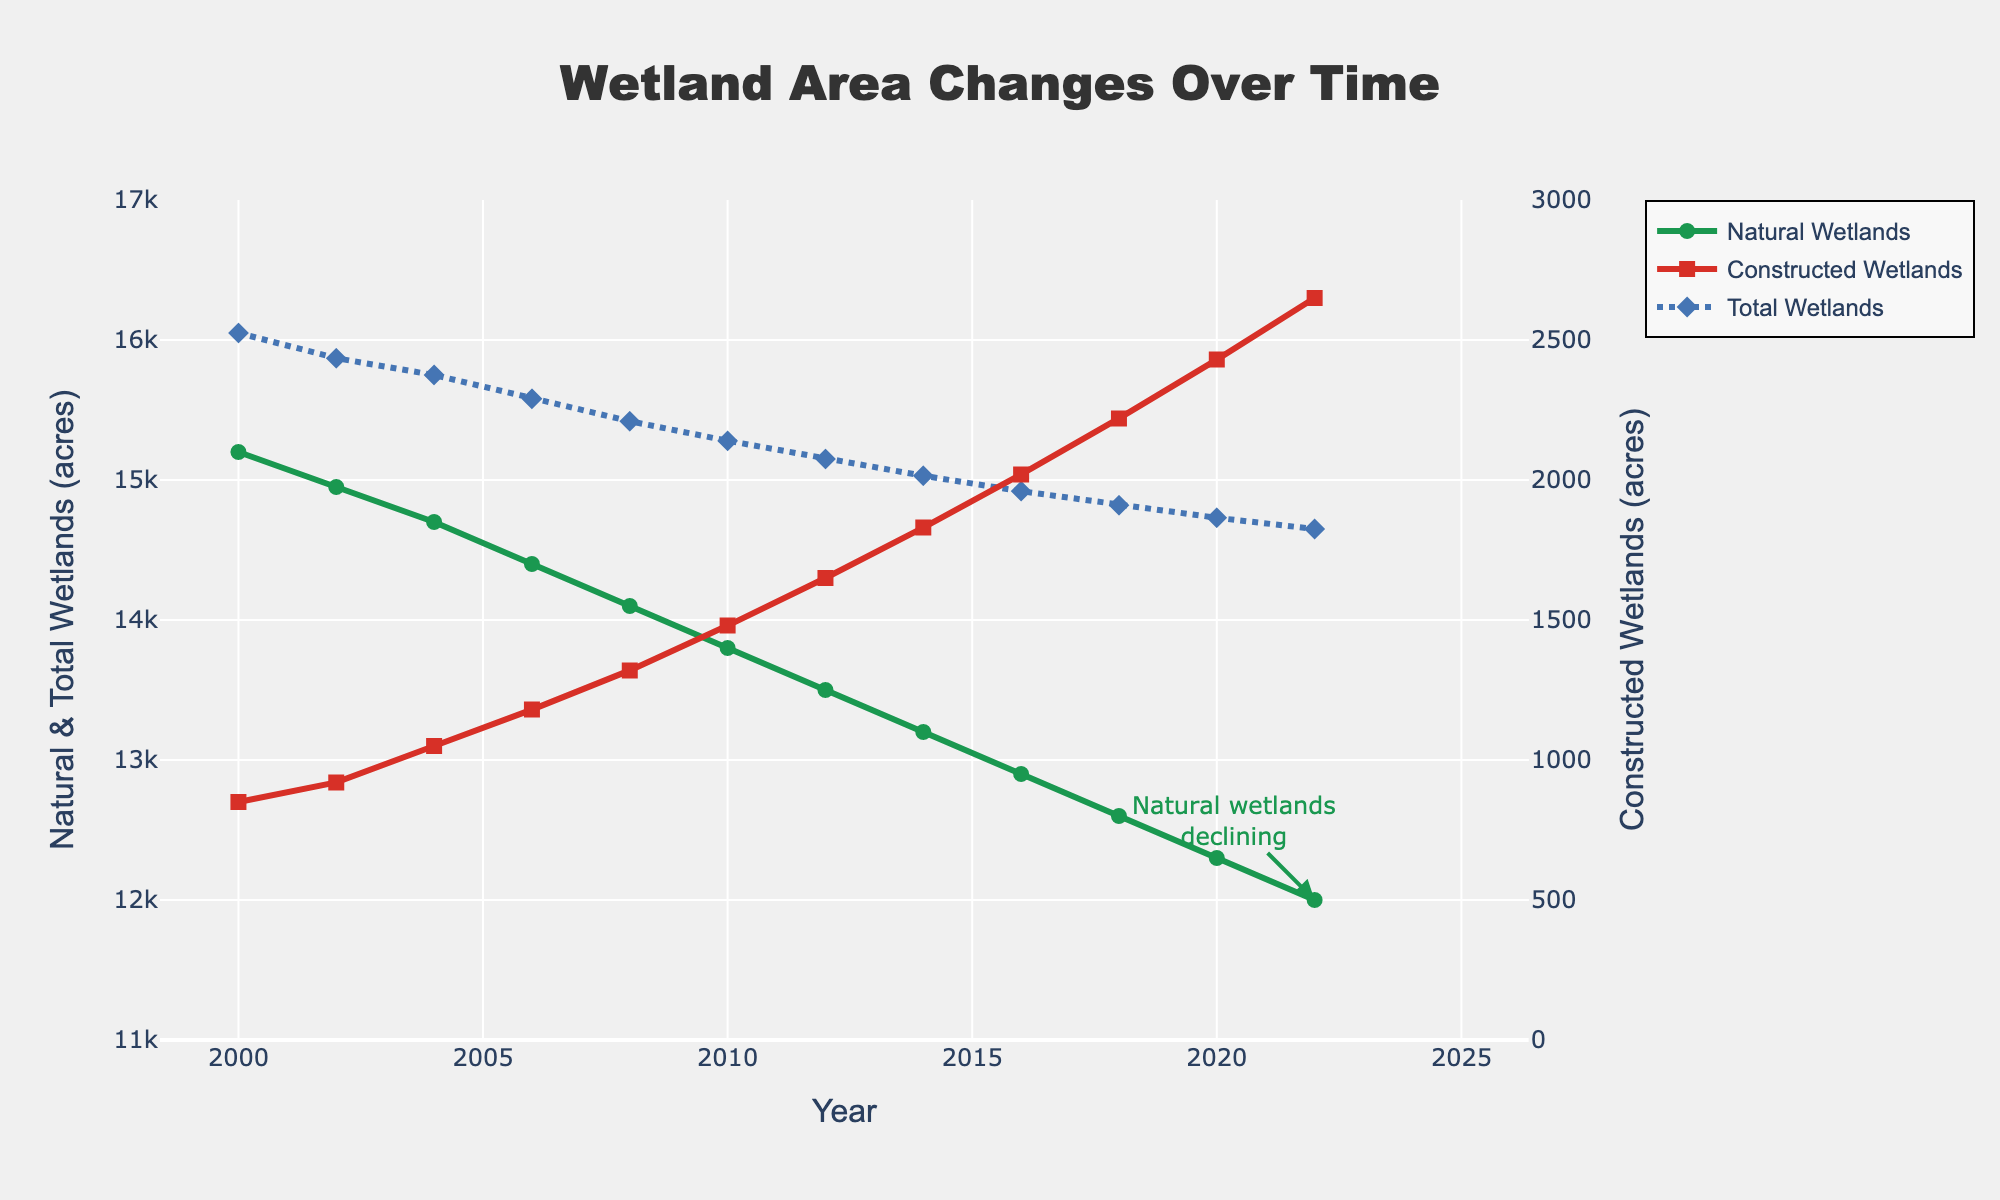What's the total wetland area in 2022? From the figure, we can see that the Total Wetlands line represents the sum of Natural Wetlands and Constructed Wetlands. In 2022, the Total Wetlands (acres) value is explicitly shown as 14,650 acres.
Answer: 14,650 acres Which type of wetland is increasing over time? Observing the trend lines in the chart, the Natural Wetlands line is declining, while the Constructed Wetlands line is increasing. This indicates that Constructed Wetlands are increasing over time.
Answer: Constructed Wetlands Has the total wetland area consistently decreased over time? Looking at the Total Wetlands line on the chart, we notice its gradual downward trend from 2000 to 2022. There are no increases; thus, the total wetland area has consistently decreased.
Answer: Yes How much did the natural wetlands decrease between 2000 and 2022? The chart shows Natural Wetlands as 15,200 acres in 2000 and 12,000 acres in 2022. Subtracting these values, 15,200 - 12,000 = 3,200 acres, the natural wetlands have decreased by 3,200 acres.
Answer: 3,200 acres In which year did the total wetland area first fall below 15,000 acres? Observing the Total Wetlands line, it first falls below the 15,000-acre mark in 2014, with the value shown as 15,030 acres. Consequently, it definitively dropped below 15,000 acres by 2016 with a value of 14,920 acres.
Answer: 2016 Comparing 2010 and 2018, which year had a higher total wetland area? In 2010, the Total Wetlands is 15,280 acres, and in 2018, it is 14,820 acres. Since 15,280 is greater than 14,820, the year 2010 had a higher total wetland area.
Answer: 2010 What was the average amount of constructed wetlands from 2000 to 2022? The constructed wetlands areas for each year (2000, 2002, 2004, ...) need to be averaged: (850 + 920 + 1050 + 1180 + 1320 + 1480 + 1650 + 1830 + 2020 + 2220 + 2430 + 2650) / 12. Calculating this: (22480 / 12) = 1,873.33 acres.
Answer: 1,873.33 acres What is the difference between the natural wetland areas in 2014 and 2022? From the chart, Natural Wetlands in 2014 are 13,200 acres and in 2022 are 12,000 acres. Subtracting these values, 13,200 - 12,000 = 1,200 acres, which is the difference.
Answer: 1,200 acres When did constructed wetlands surpass 2,000 acres? Observing the Constructed Wetlands trend line, it first exceeds the 2,000-acre mark in 2016, with a value of 2,020 acres.
Answer: 2016 